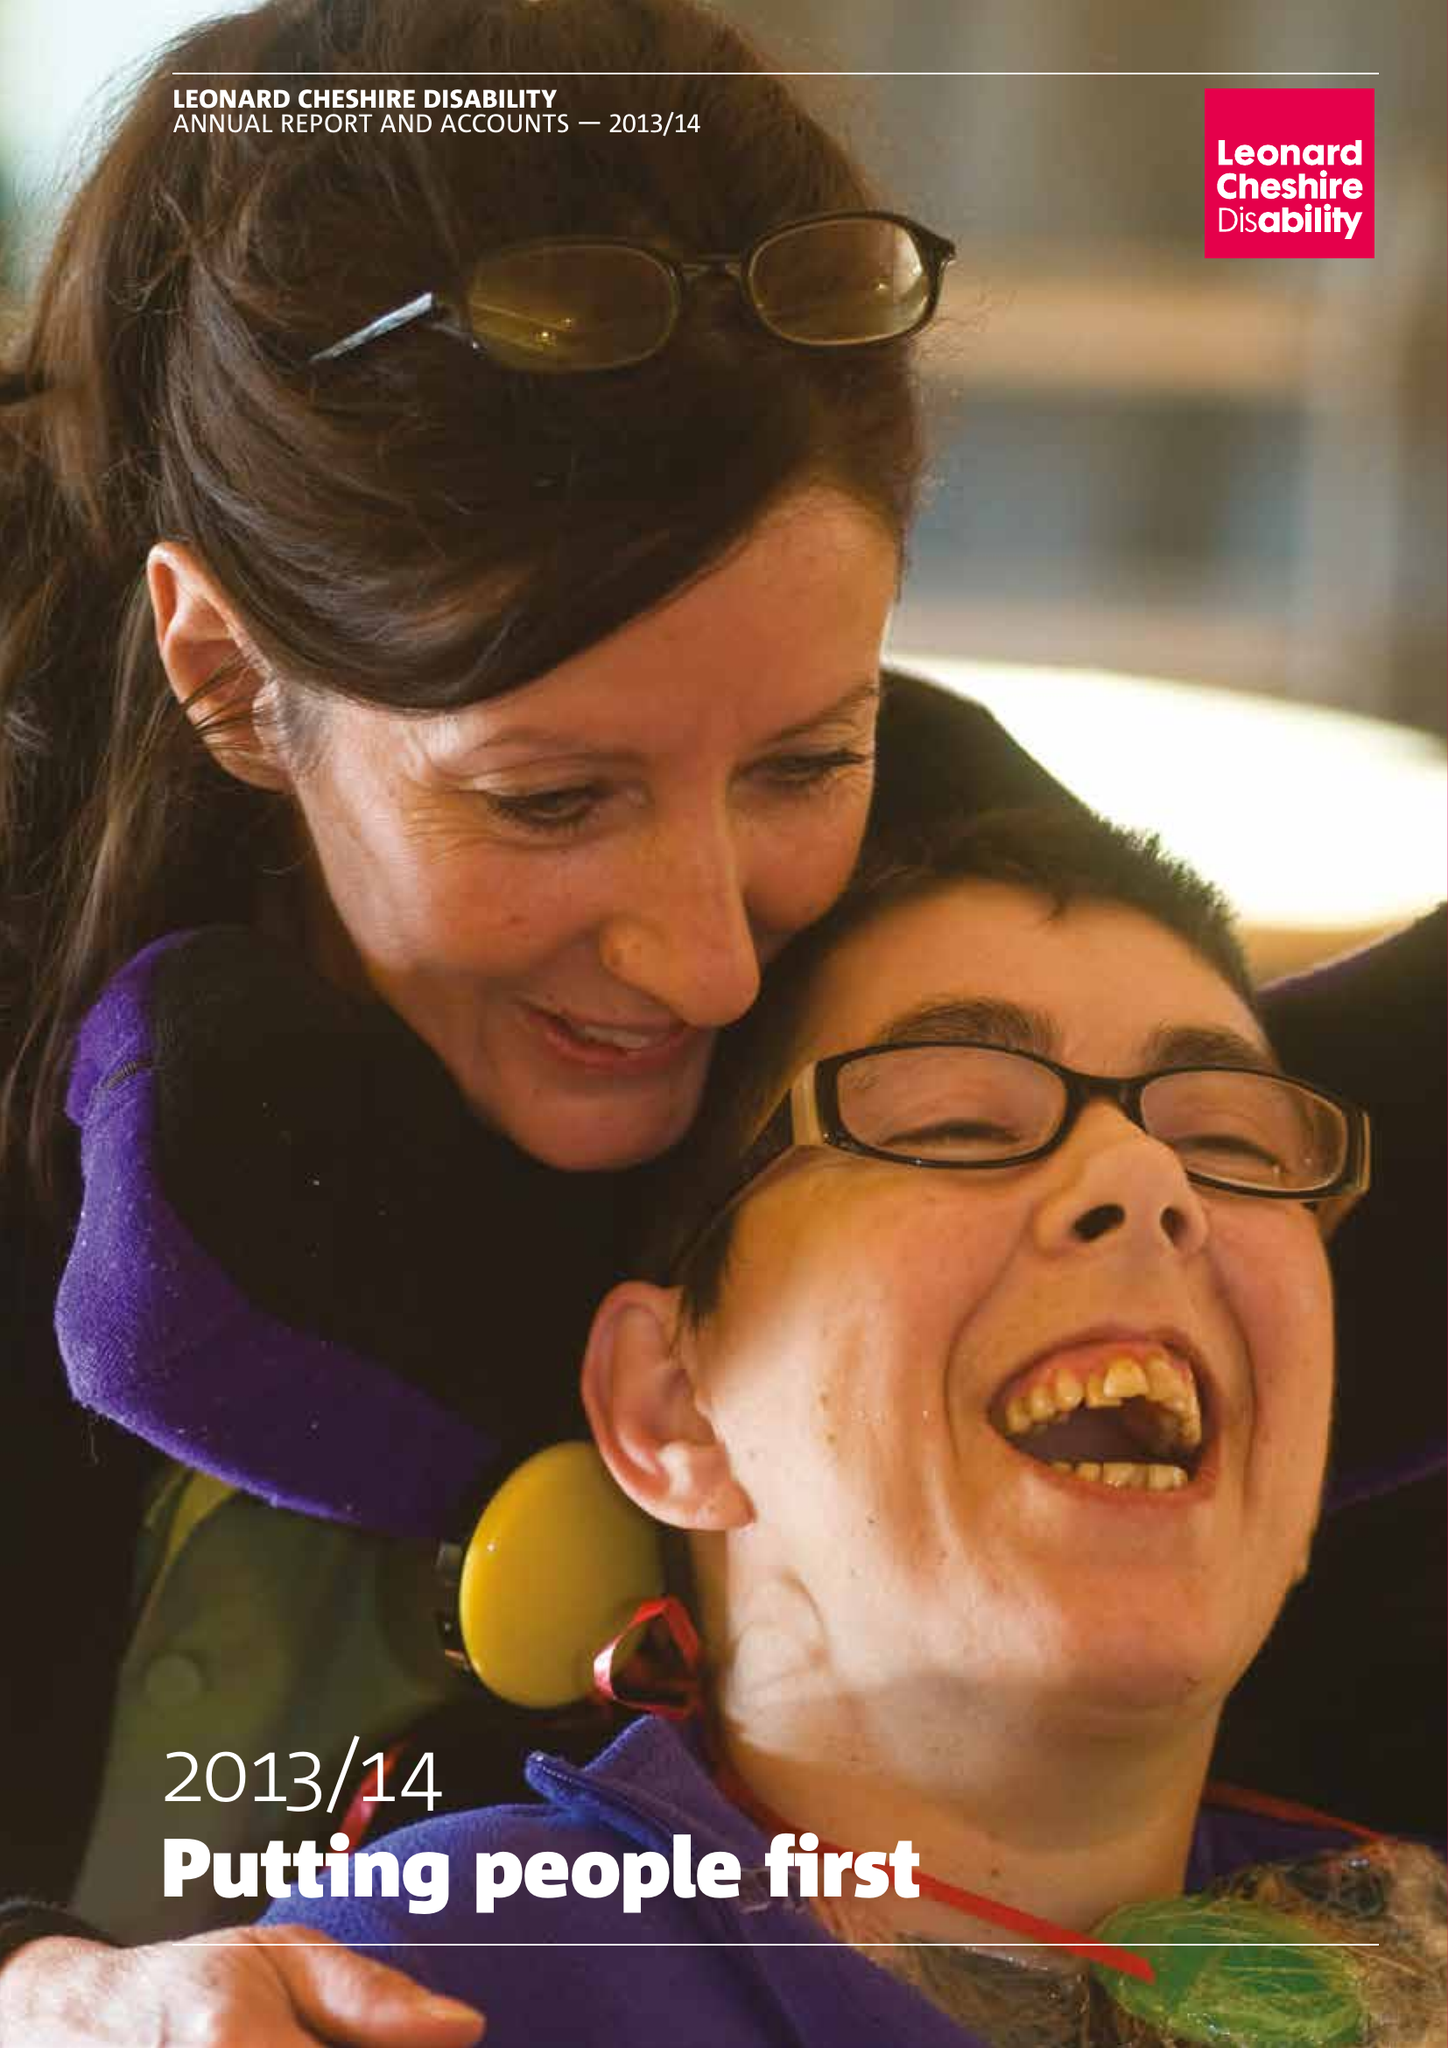What is the value for the spending_annually_in_british_pounds?
Answer the question using a single word or phrase. 153541000.00 